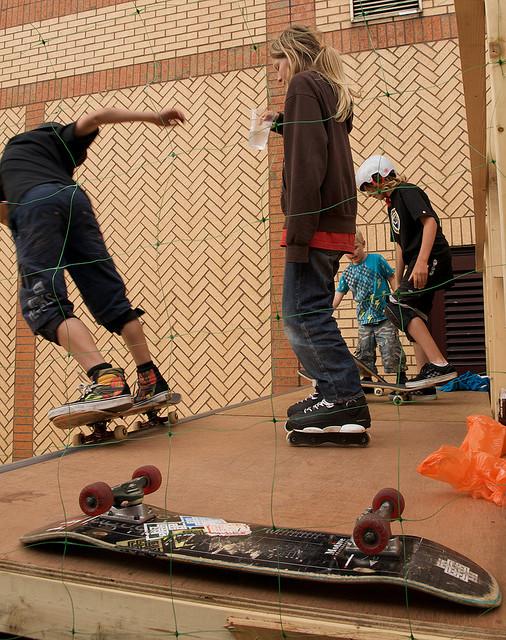Are all the skateboards being used?
Short answer required. No. How many people?
Be succinct. 4. Are they skating?
Write a very short answer. Yes. 